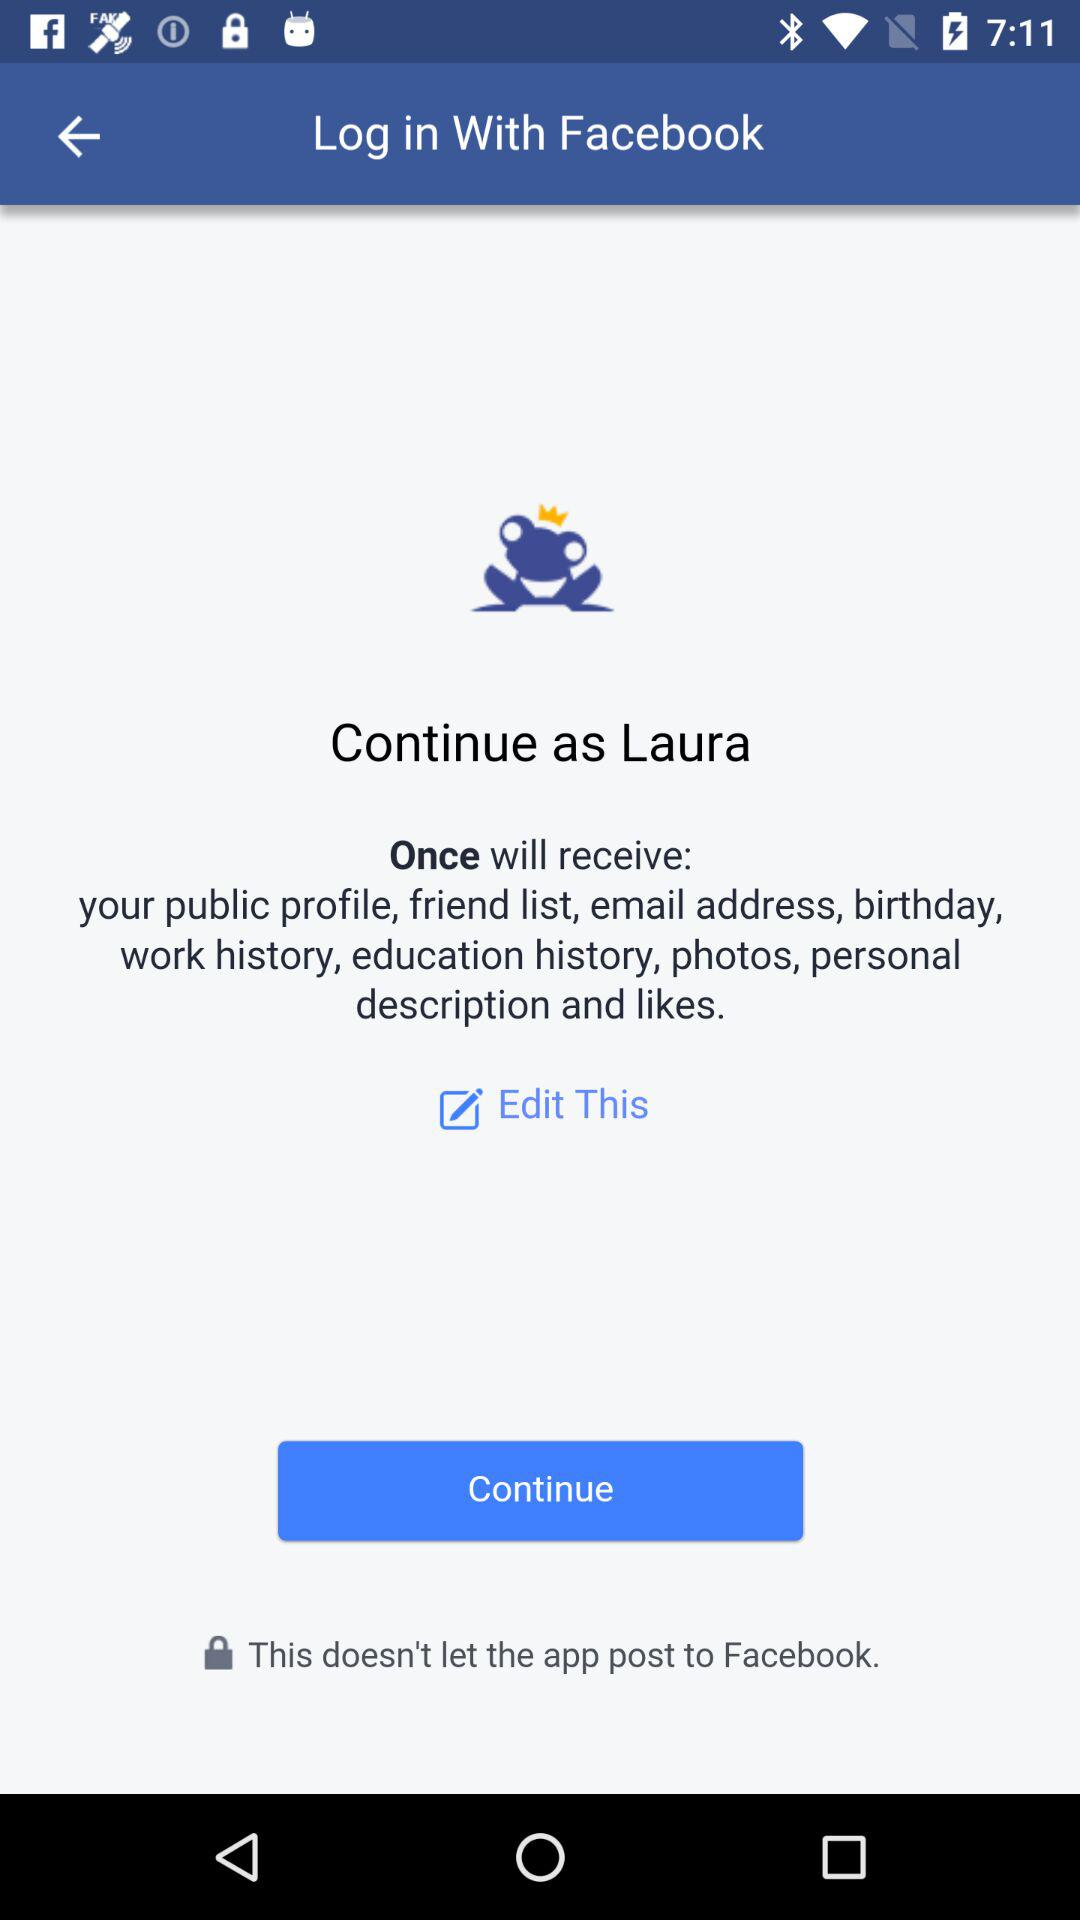Which option is selected?
When the provided information is insufficient, respond with <no answer>. <no answer> 